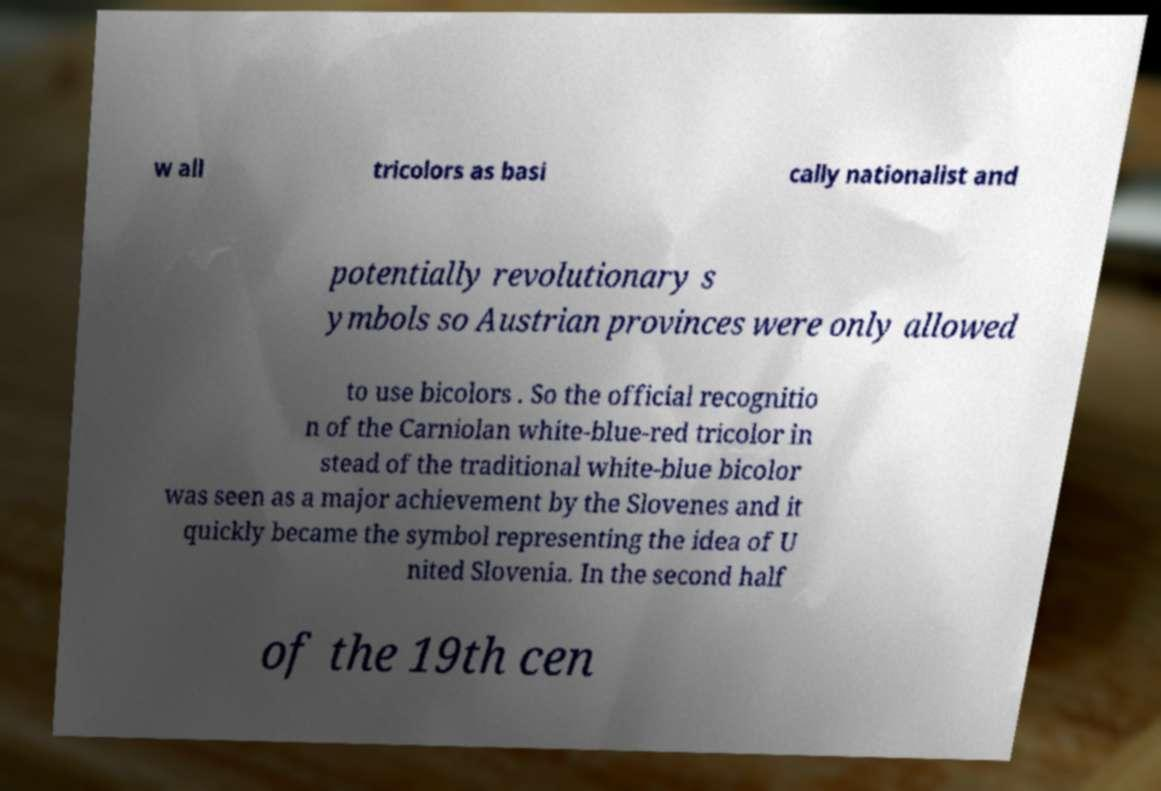Please identify and transcribe the text found in this image. w all tricolors as basi cally nationalist and potentially revolutionary s ymbols so Austrian provinces were only allowed to use bicolors . So the official recognitio n of the Carniolan white-blue-red tricolor in stead of the traditional white-blue bicolor was seen as a major achievement by the Slovenes and it quickly became the symbol representing the idea of U nited Slovenia. In the second half of the 19th cen 